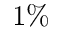Convert formula to latex. <formula><loc_0><loc_0><loc_500><loc_500>1 \%</formula> 